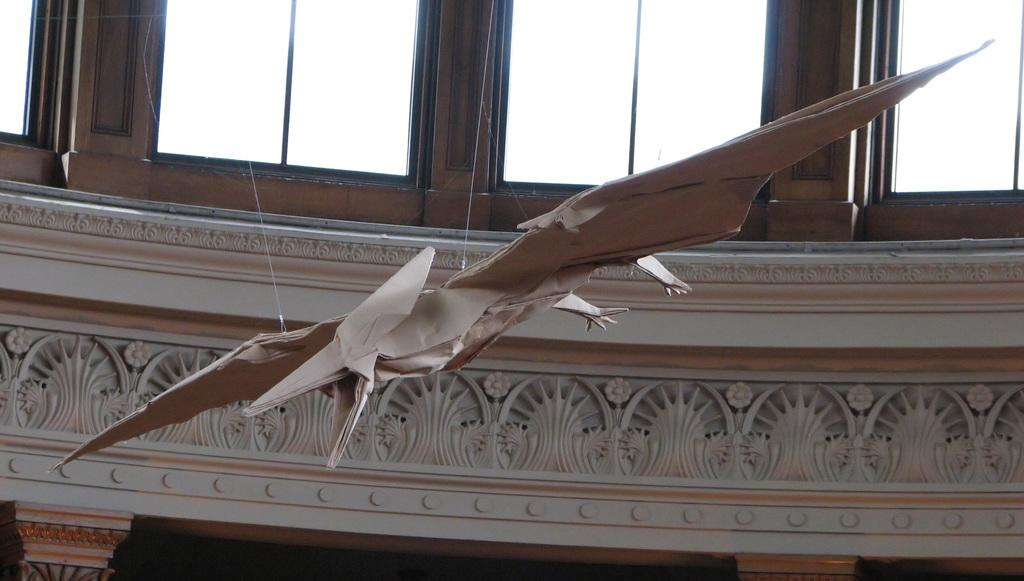What is the main subject of the image? There is a paper craft in the image. What can be seen in the background of the image? There are glasses and a wall in the background of the image. What type of pet is sitting on the paper craft in the image? There is no pet present on the paper craft in the image. What kind of meeting is taking place in the image? There is no meeting depicted in the image; it features a paper craft and a background with glasses and a wall. 